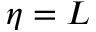Convert formula to latex. <formula><loc_0><loc_0><loc_500><loc_500>\eta = L</formula> 